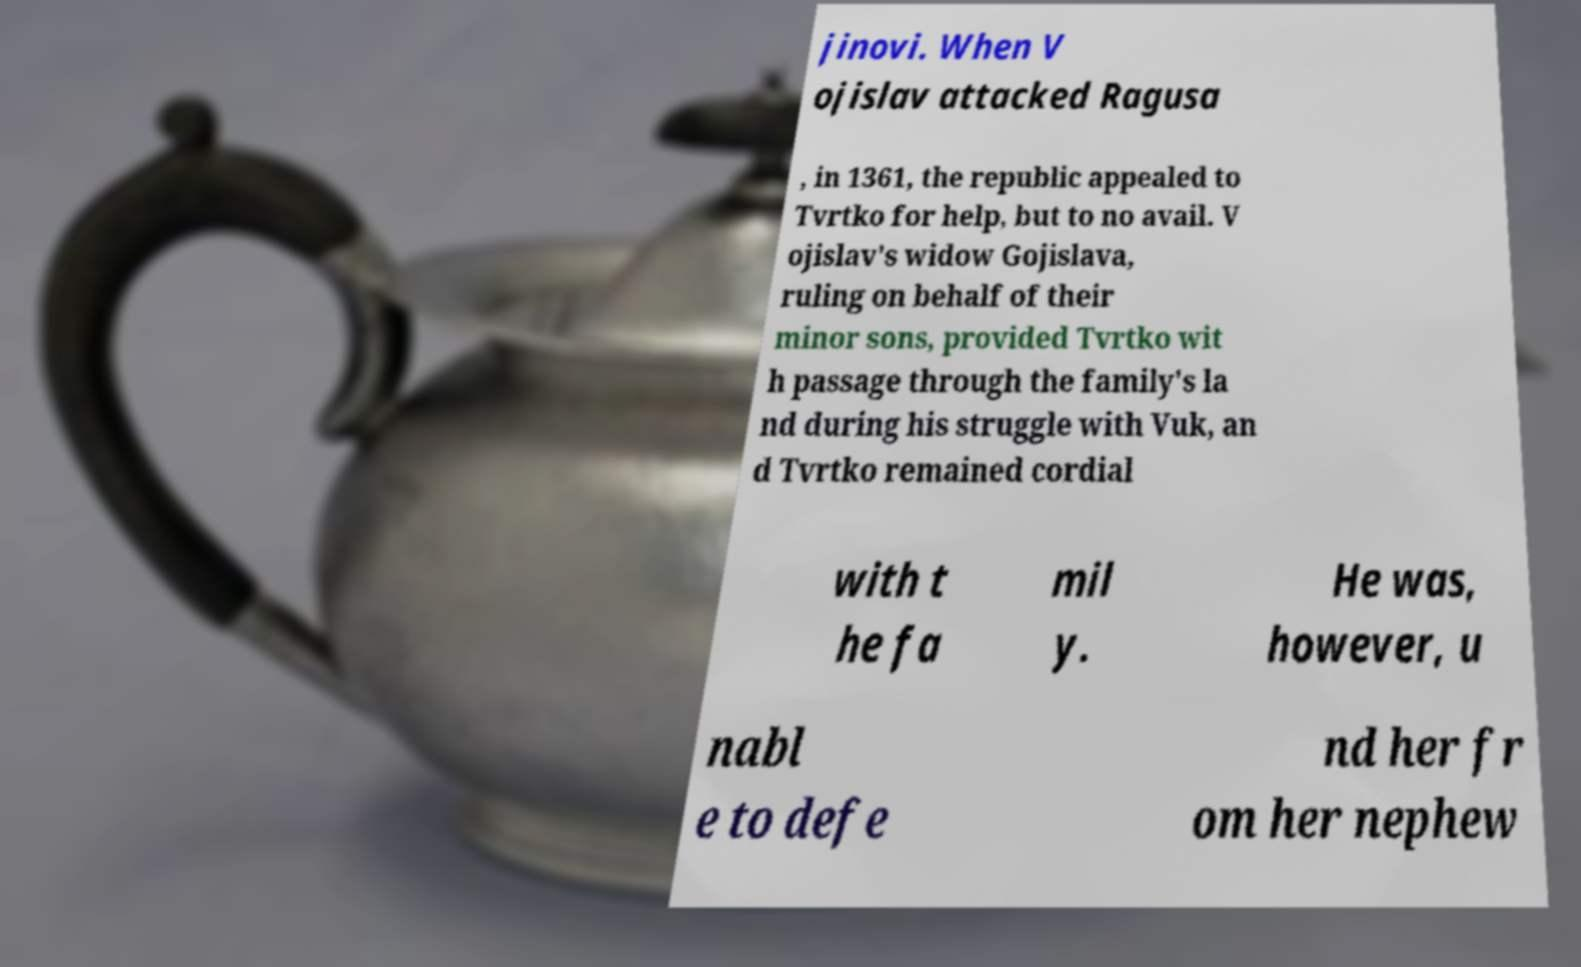Please identify and transcribe the text found in this image. jinovi. When V ojislav attacked Ragusa , in 1361, the republic appealed to Tvrtko for help, but to no avail. V ojislav's widow Gojislava, ruling on behalf of their minor sons, provided Tvrtko wit h passage through the family's la nd during his struggle with Vuk, an d Tvrtko remained cordial with t he fa mil y. He was, however, u nabl e to defe nd her fr om her nephew 